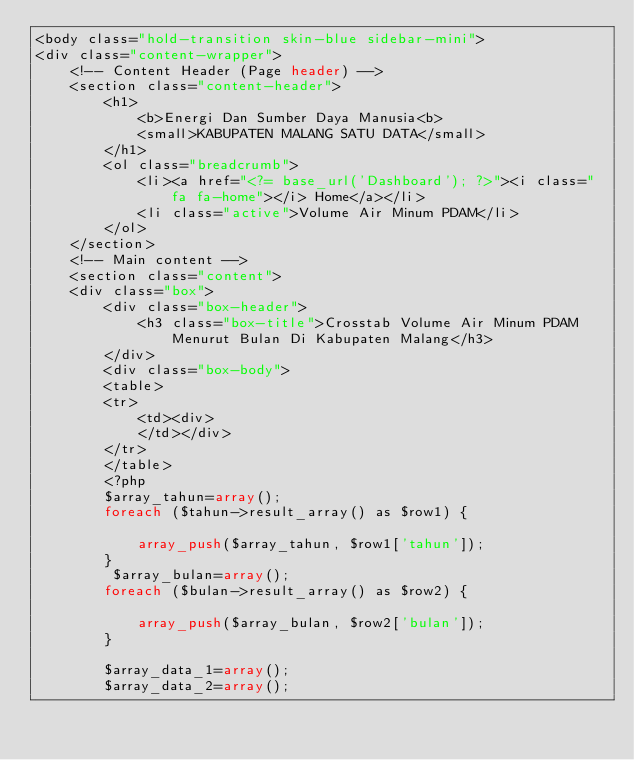Convert code to text. <code><loc_0><loc_0><loc_500><loc_500><_PHP_><body class="hold-transition skin-blue sidebar-mini">
<div class="content-wrapper">
    <!-- Content Header (Page header) -->
    <section class="content-header">
        <h1>
            <b>Energi Dan Sumber Daya Manusia<b>
            <small>KABUPATEN MALANG SATU DATA</small>
        </h1>
        <ol class="breadcrumb">
            <li><a href="<?= base_url('Dashboard'); ?>"><i class="fa fa-home"></i> Home</a></li>
            <li class="active">Volume Air Minum PDAM</li>
        </ol>
    </section>
    <!-- Main content -->
    <section class="content">
    <div class="box">
        <div class="box-header">
            <h3 class="box-title">Crosstab Volume Air Minum PDAM Menurut Bulan Di Kabupaten Malang</h3>
        </div>
        <div class="box-body">
        <table>
        <tr>
            <td><div>
            </td></div>
        </tr>
        </table>
        <?php
        $array_tahun=array();
        foreach ($tahun->result_array() as $row1) {
           
            array_push($array_tahun, $row1['tahun']);
        }
         $array_bulan=array();
        foreach ($bulan->result_array() as $row2) {
           
            array_push($array_bulan, $row2['bulan']);
        }

        $array_data_1=array();
        $array_data_2=array();</code> 